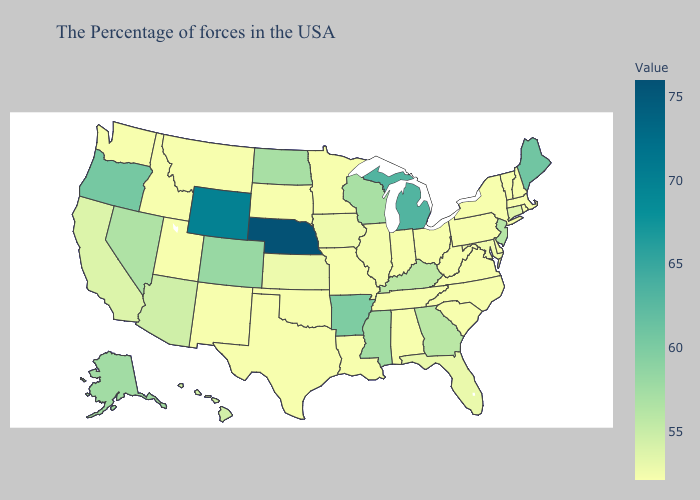Does Georgia have the lowest value in the South?
Concise answer only. No. Does Kansas have a higher value than Wisconsin?
Answer briefly. No. Which states have the highest value in the USA?
Quick response, please. Nebraska. Does West Virginia have the highest value in the South?
Give a very brief answer. No. Does Virginia have the lowest value in the South?
Answer briefly. Yes. Does Rhode Island have the highest value in the Northeast?
Be succinct. No. 